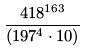<formula> <loc_0><loc_0><loc_500><loc_500>\frac { 4 1 8 ^ { 1 6 3 } } { ( 1 9 7 ^ { 4 } \cdot 1 0 ) }</formula> 